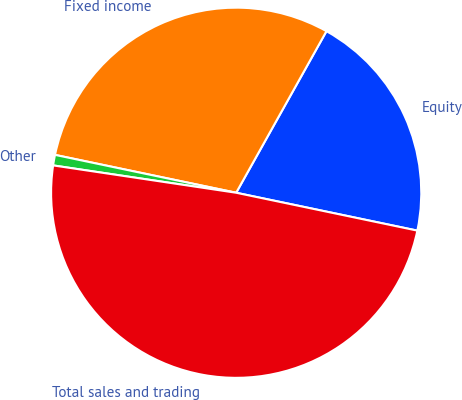Convert chart to OTSL. <chart><loc_0><loc_0><loc_500><loc_500><pie_chart><fcel>Equity<fcel>Fixed income<fcel>Other<fcel>Total sales and trading<nl><fcel>20.17%<fcel>29.83%<fcel>0.92%<fcel>49.08%<nl></chart> 